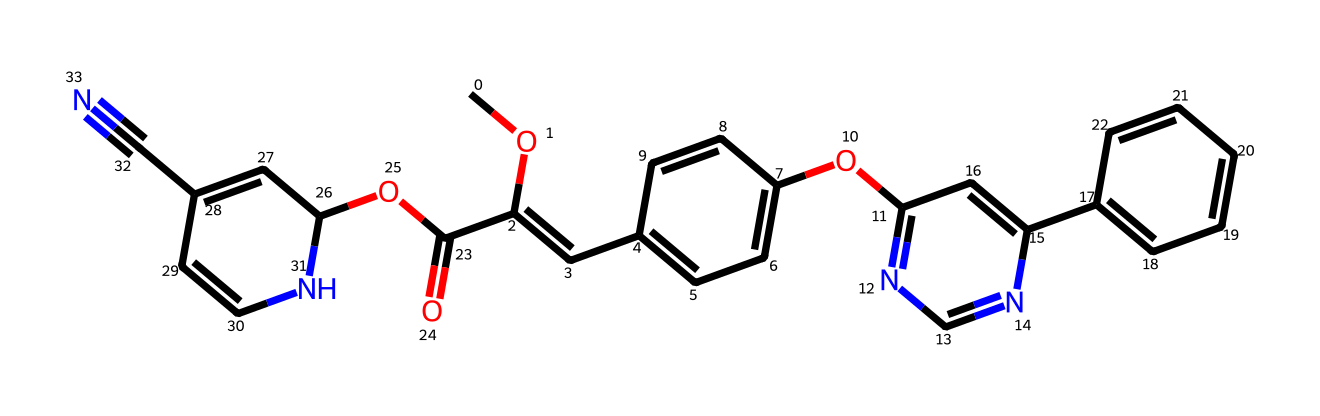What is the molecular formula of azoxystrobin? To determine the molecular formula, we can count the number of each type of atom present in the SMILES representation. Analyzing the SMILES shows there are 21 carbon (C), 24 hydrogen (H), 5 nitrogen (N), and 5 oxygen (O) atoms. Therefore, the molecular formula is C21H24N5O5.
Answer: C21H24N5O5 How many rings are present in the structure of azoxystrobin? By examining the SMILES, we can identify the cyclic structures indicated by the presence of numbers. There are three instances where numbers are introduced to denote the start and end of a ring. Therefore, there are three rings in the chemical structure.
Answer: 3 What kind of functional groups are present in azoxystrobin? The SMILES notation reveals multiple functional groups, including methoxy (-OCH3), carbonyl (C=O), cyano (-C≡N), and a nitrogen-containing heterocycle. Identifying these groups based on their structural representations leads to the conclusion that these functional groups are present in the compound.
Answer: methoxy, carbonyl, cyano What is the primary use of azoxystrobin? Azoxystrobin is primarily used as a fungicide in agriculture. The structure suggests that it possesses properties effective against various fungal pathogens, which aligns with its known application in controlling diseases in crops.
Answer: fungicide What is the significance of the nitrogen atoms in azoxystrobin's structure? The presence of multiple nitrogen atoms in the structure indicates that the compound may have bioactive properties, such as disrupting fungal cell metabolism. Nitrogen atoms' positioning also influences the fungicidal activity of azoxystrobin. Therefore, the nitrogen atoms are critical to its function.
Answer: bioactivity 